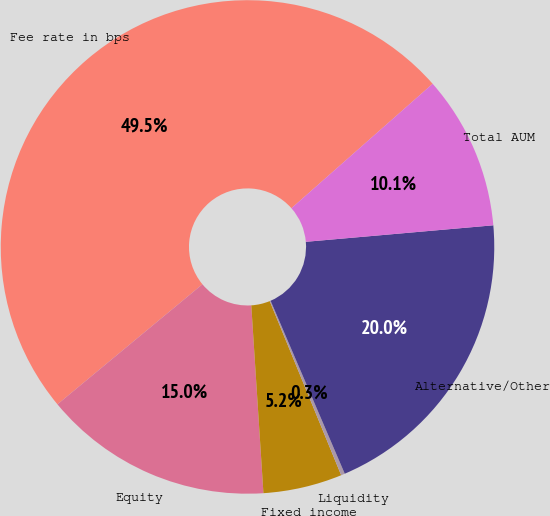Convert chart to OTSL. <chart><loc_0><loc_0><loc_500><loc_500><pie_chart><fcel>Fee rate in bps<fcel>Equity<fcel>Fixed income<fcel>Liquidity<fcel>Alternative/Other<fcel>Total AUM<nl><fcel>49.51%<fcel>15.02%<fcel>5.17%<fcel>0.25%<fcel>19.95%<fcel>10.1%<nl></chart> 